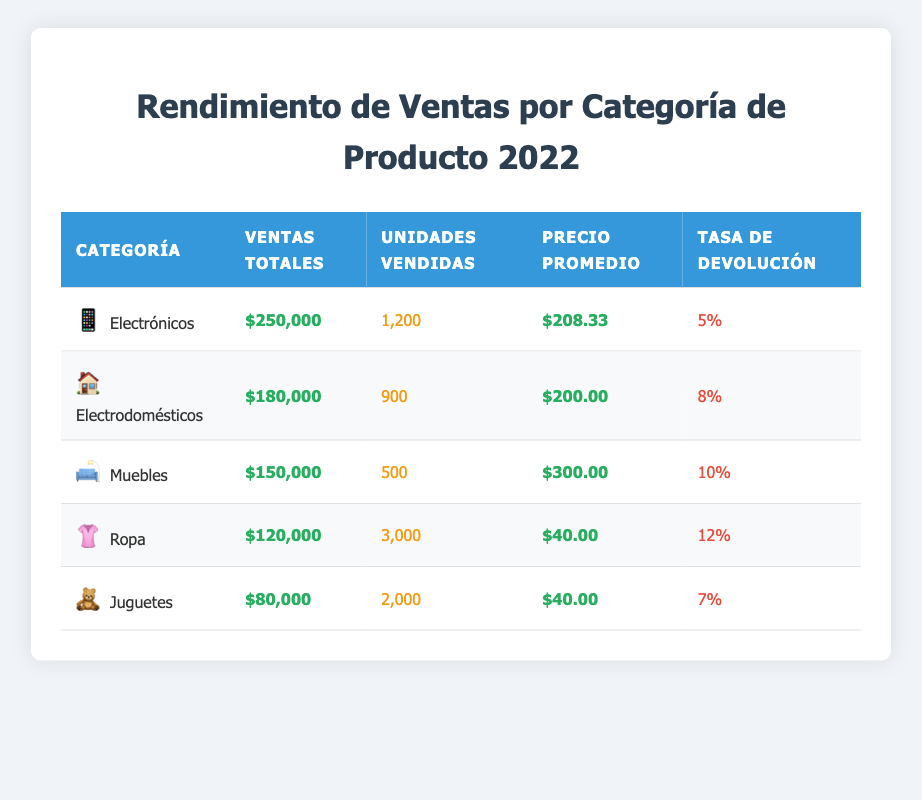What is the total sales amount for the Electronics category? The total sales for the Electronics category is found directly in the table under the "Ventas Totales" column for that category, which states $250,000.
Answer: $250,000 Which product category has the highest return rate? To determine the highest return rate, we compare the values listed in the "Tasa de Devolución" column. The Clothing category has a return rate of 12%, which is the highest among all categories listed.
Answer: Clothing What is the average price of Furniture? The average price for the Furniture category can be found in the "Precio Promedio" column, which lists it as $300.00.
Answer: $300.00 How many units were sold across all product categories? To find the total units sold across all categories, we add the values in the "Unidades Vendidas" column: 1200 + 900 + 500 + 3000 + 2000 = 3600 units sold in total.
Answer: 3600 Is the average price of Toys higher than that of Home Appliances? The average price for Toys is $40.00, and for Home Appliances, it is $200.00. Since $40.00 is less than $200.00, the statement is false.
Answer: No What is the difference between total sales of Electronics and Furniture? The total sales for Electronics is $250,000 and for Furniture, it is $150,000. The difference can be calculated by subtracting the two amounts: $250,000 - $150,000 = $100,000.
Answer: $100,000 Which product category sold the most units, and how many units were sold? The category that sold the most units is Clothing, with 3,000 units sold, as indicated in the "Unidades Vendidas" column.
Answer: Clothing, 3000 units If we exclude the Clothing category, what is the total sales amount of the remaining categories? We calculate the total sales amount for all categories except Clothing: $250,000 (Electronics) + $180,000 (Home Appliances) + $150,000 (Furniture) + $80,000 (Toys) = $660,000.
Answer: $660,000 